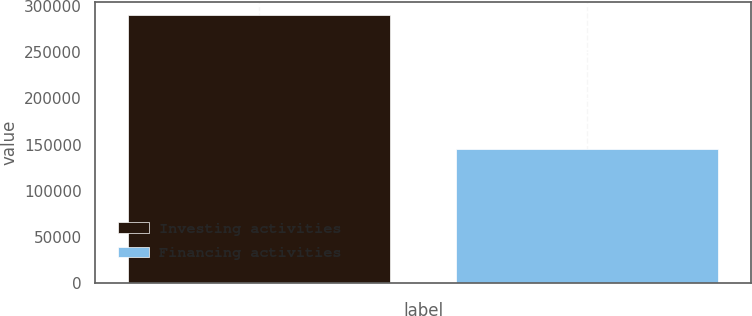<chart> <loc_0><loc_0><loc_500><loc_500><bar_chart><fcel>Investing activities<fcel>Financing activities<nl><fcel>290346<fcel>145665<nl></chart> 